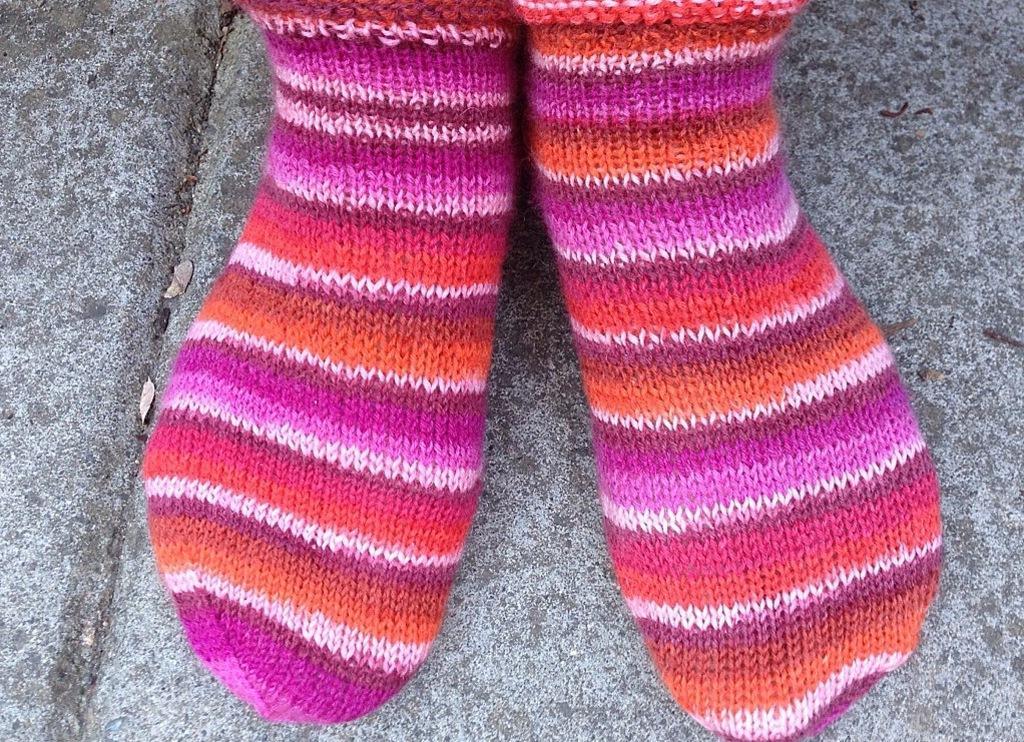Please provide a concise description of this image. This is a zoomed in picture. In the center we can see the legs of a person wearing colorful socks. In the background we can see the ground. 